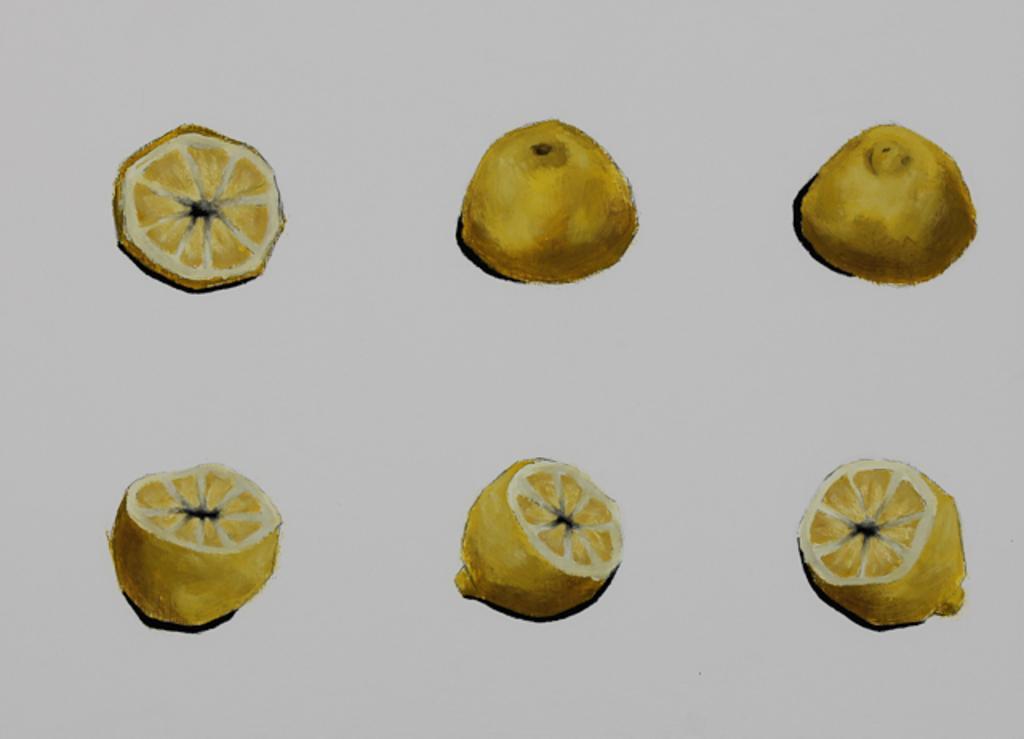Describe this image in one or two sentences. In this image I can see six pieces of a lemon. The background is ash in color. This image looks like a painting. 